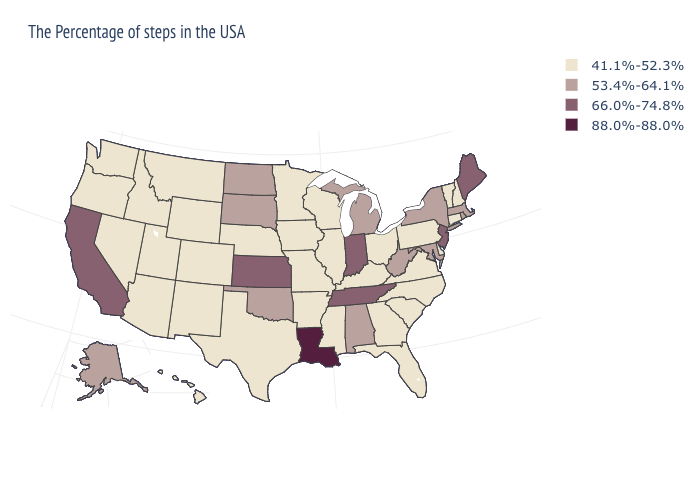Name the states that have a value in the range 66.0%-74.8%?
Quick response, please. Maine, New Jersey, Indiana, Tennessee, Kansas, California. Which states have the lowest value in the USA?
Concise answer only. New Hampshire, Vermont, Connecticut, Delaware, Pennsylvania, Virginia, North Carolina, South Carolina, Ohio, Florida, Georgia, Kentucky, Wisconsin, Illinois, Mississippi, Missouri, Arkansas, Minnesota, Iowa, Nebraska, Texas, Wyoming, Colorado, New Mexico, Utah, Montana, Arizona, Idaho, Nevada, Washington, Oregon, Hawaii. What is the value of Hawaii?
Keep it brief. 41.1%-52.3%. Name the states that have a value in the range 88.0%-88.0%?
Quick response, please. Louisiana. Name the states that have a value in the range 53.4%-64.1%?
Answer briefly. Massachusetts, Rhode Island, New York, Maryland, West Virginia, Michigan, Alabama, Oklahoma, South Dakota, North Dakota, Alaska. Among the states that border North Dakota , does Minnesota have the lowest value?
Short answer required. Yes. Does Texas have the lowest value in the South?
Keep it brief. Yes. Name the states that have a value in the range 66.0%-74.8%?
Quick response, please. Maine, New Jersey, Indiana, Tennessee, Kansas, California. Among the states that border Pennsylvania , does New Jersey have the highest value?
Give a very brief answer. Yes. What is the highest value in the USA?
Answer briefly. 88.0%-88.0%. What is the lowest value in the Northeast?
Give a very brief answer. 41.1%-52.3%. Does Maine have the highest value in the Northeast?
Keep it brief. Yes. Does Rhode Island have a lower value than Kansas?
Keep it brief. Yes. What is the highest value in the Northeast ?
Concise answer only. 66.0%-74.8%. Name the states that have a value in the range 66.0%-74.8%?
Write a very short answer. Maine, New Jersey, Indiana, Tennessee, Kansas, California. 